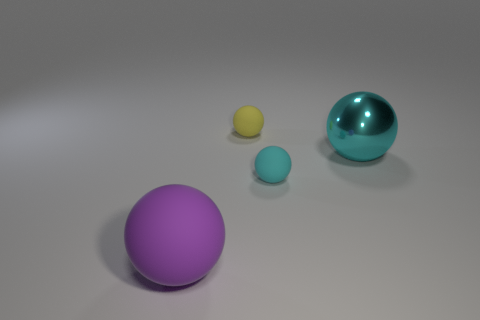What might be the textures of the objects? The large sphere in the foreground has a matte texture with a diffuse reflection, suggesting a soft or possibly rubbery exterior. The large shiny sphere at the back appears to have a reflective, possibly metallic or polished plastic surface. The smaller spheres seem to share a similar matte finish, akin to the larger one in the foreground. 